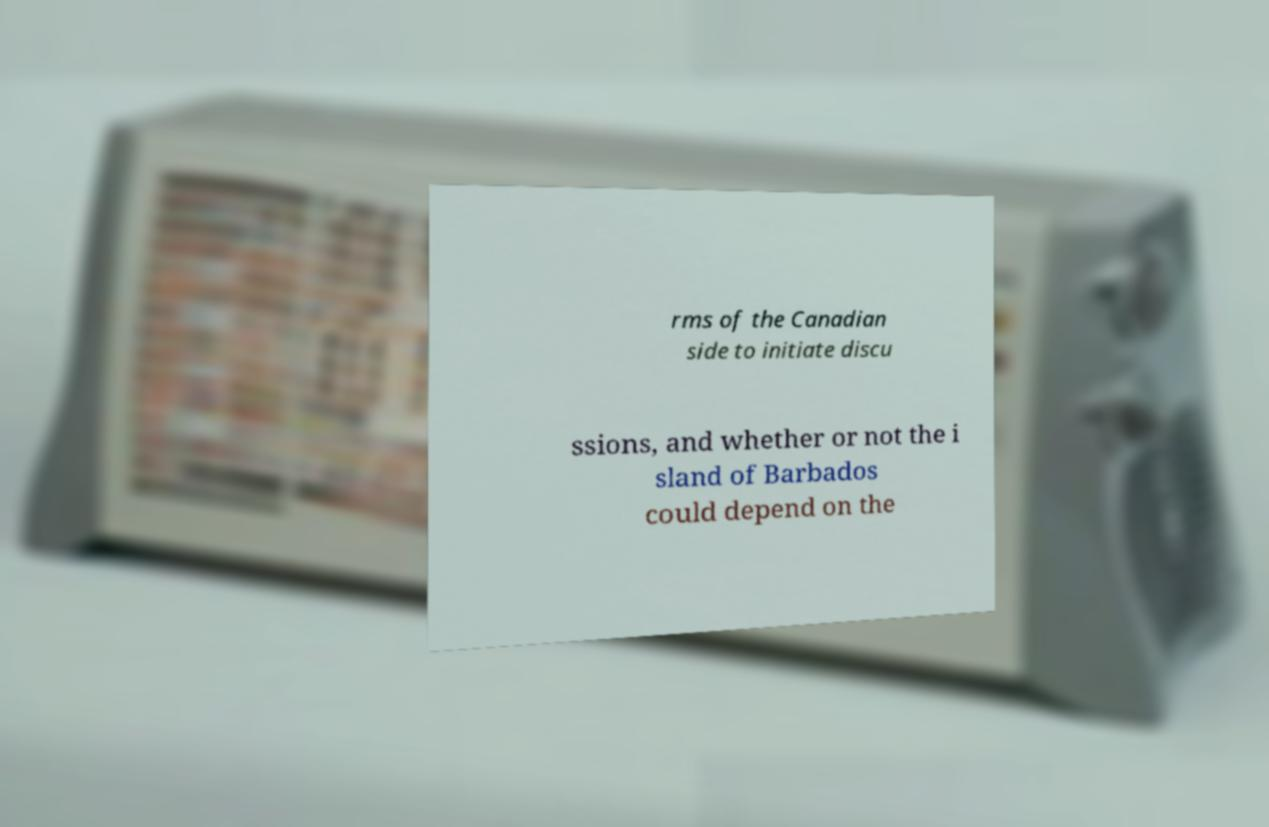What messages or text are displayed in this image? I need them in a readable, typed format. rms of the Canadian side to initiate discu ssions, and whether or not the i sland of Barbados could depend on the 